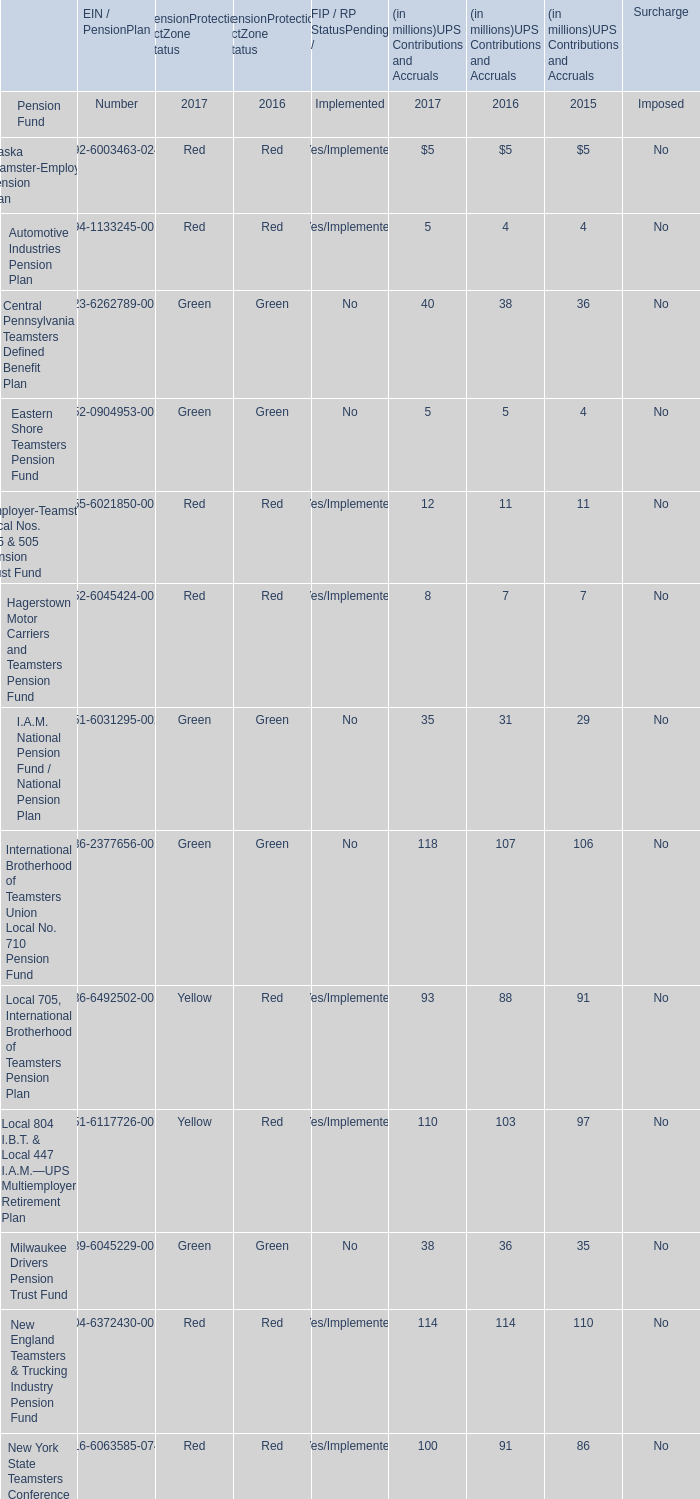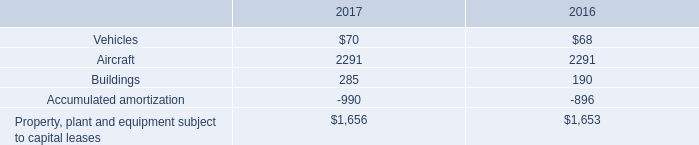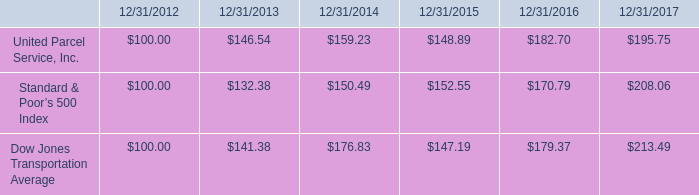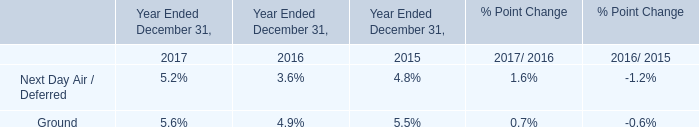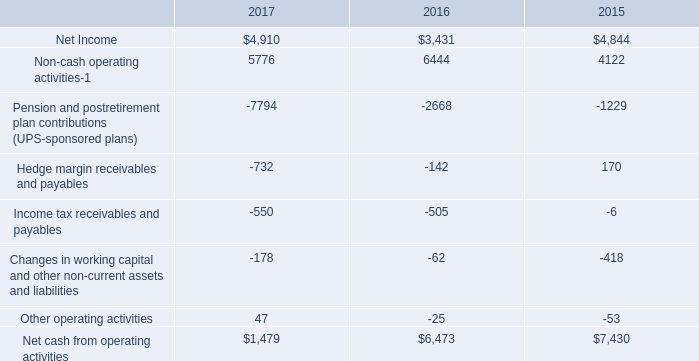what is the total cumulative percentage return on investment on class b common stock for the five years ended 122/31/2017? 
Computations: ((195.75 - 100.00) / 100.00)
Answer: 0.9575. 